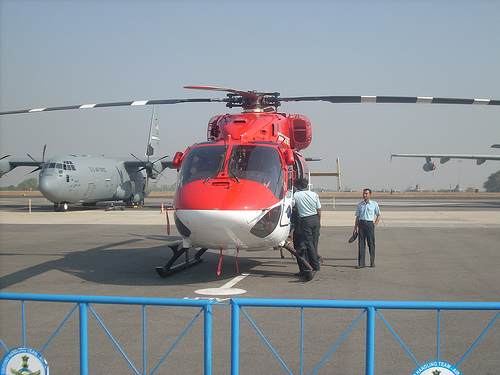<image>
Is there a shirt on the man? No. The shirt is not positioned on the man. They may be near each other, but the shirt is not supported by or resting on top of the man. Is the plane to the left of the chopper? Yes. From this viewpoint, the plane is positioned to the left side relative to the chopper. 